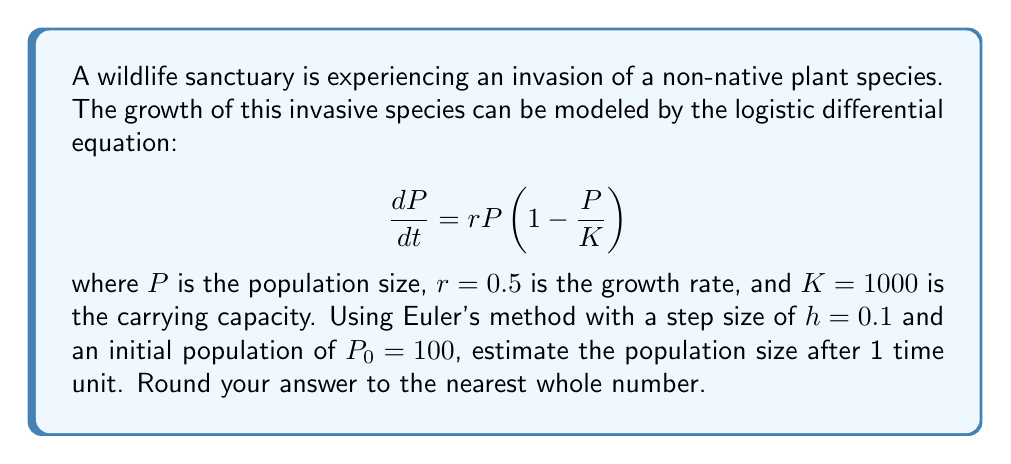Give your solution to this math problem. To solve this problem using Euler's method, we follow these steps:

1) Euler's method is given by the formula:
   $$P_{n+1} = P_n + h \cdot f(t_n, P_n)$$
   where $f(t, P) = \frac{dP}{dt} = rP(1 - \frac{P}{K})$

2) We're given:
   $r = 0.5$, $K = 1000$, $h = 0.1$, $P_0 = 100$, and we need to calculate up to $t = 1$

3) We'll need to iterate 10 times to reach $t = 1$ (since $0.1 \times 10 = 1$)

4) For each step, we calculate:
   $$P_{n+1} = P_n + 0.1 \cdot (0.5 \cdot P_n \cdot (1 - \frac{P_n}{1000}))$$

5) Let's calculate the first few steps:

   Step 1: $P_1 = 100 + 0.1 \cdot (0.5 \cdot 100 \cdot (1 - \frac{100}{1000})) = 104.5$
   
   Step 2: $P_2 = 104.5 + 0.1 \cdot (0.5 \cdot 104.5 \cdot (1 - \frac{104.5}{1000})) = 109.1525$
   
   Step 3: $P_3 = 109.1525 + 0.1 \cdot (0.5 \cdot 109.1525 \cdot (1 - \frac{109.1525}{1000})) = 113.9881$

6) Continuing this process for 7 more steps, we get:

   $P_{10} \approx 155.1327$

7) Rounding to the nearest whole number, we get 155.
Answer: 155 